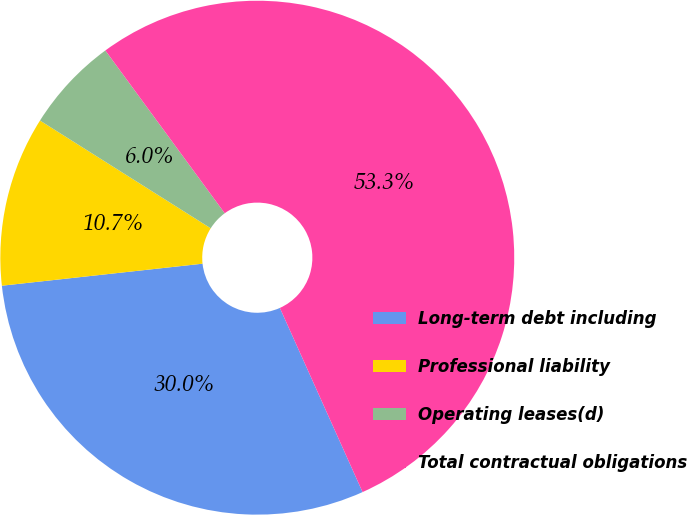Convert chart to OTSL. <chart><loc_0><loc_0><loc_500><loc_500><pie_chart><fcel>Long-term debt including<fcel>Professional liability<fcel>Operating leases(d)<fcel>Total contractual obligations<nl><fcel>29.98%<fcel>10.7%<fcel>5.97%<fcel>53.35%<nl></chart> 